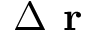Convert formula to latex. <formula><loc_0><loc_0><loc_500><loc_500>\Delta r</formula> 